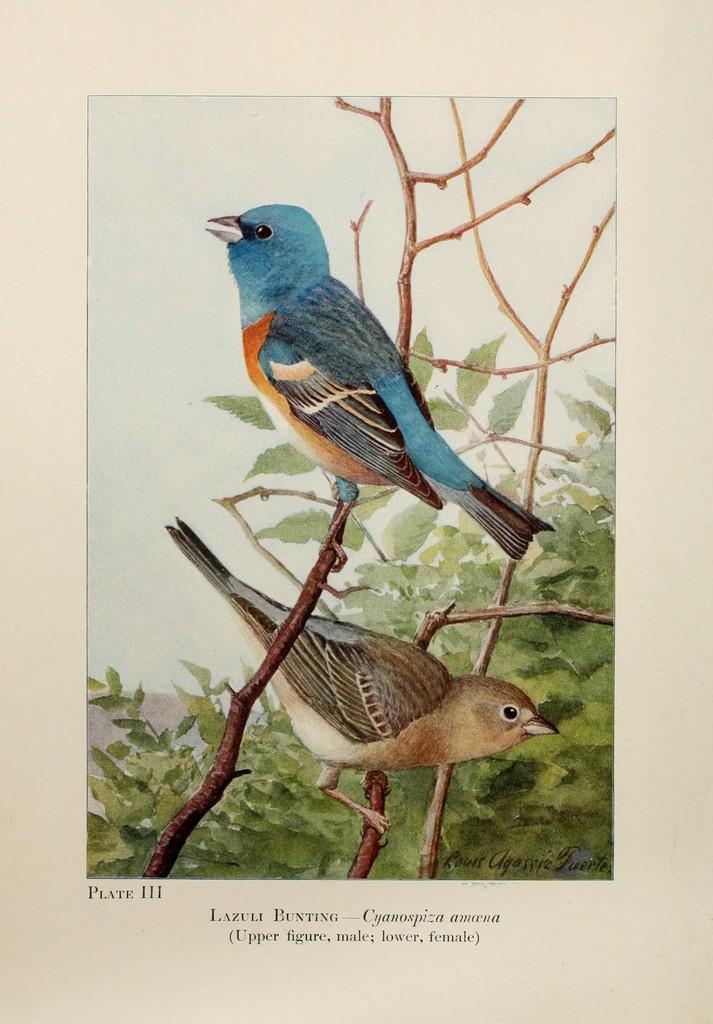Could you give a brief overview of what you see in this image? This is a poster and in this poster we can see two birds on branches, leaves and at the bottom of this picture we can see some text. 